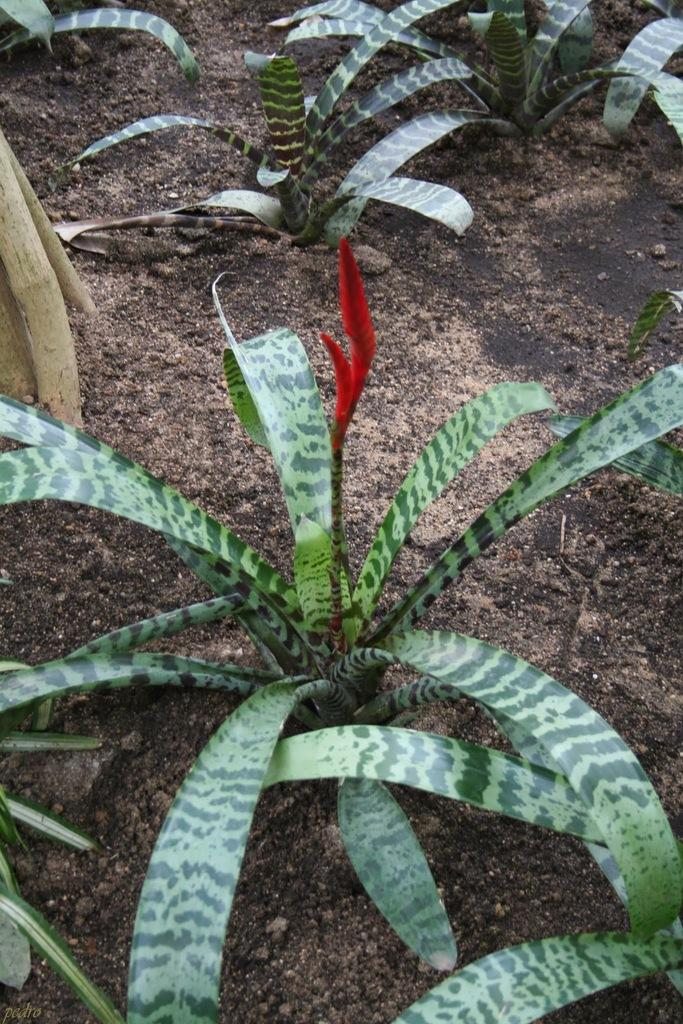What type of living organisms can be seen in the image? Plants and a flower are visible in the image. What is the color of the flower in the image? The flower in the image is red. What object is made of wood and present in the image? There is a wooden stick in the image. What is the current profit of the flower in the image? There is no information about profit in the image, as it is a still image of plants and a flower. 